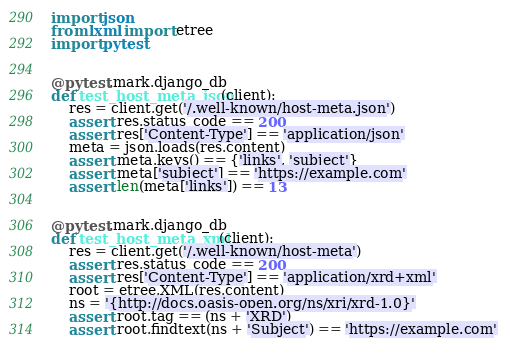Convert code to text. <code><loc_0><loc_0><loc_500><loc_500><_Python_>import json
from lxml import etree
import pytest


@pytest.mark.django_db
def test_host_meta_json(client):
    res = client.get('/.well-known/host-meta.json')
    assert res.status_code == 200
    assert res['Content-Type'] == 'application/json'
    meta = json.loads(res.content)
    assert meta.keys() == {'links', 'subject'}
    assert meta['subject'] == 'https://example.com'
    assert len(meta['links']) == 13


@pytest.mark.django_db
def test_host_meta_xml(client):
    res = client.get('/.well-known/host-meta')
    assert res.status_code == 200
    assert res['Content-Type'] == 'application/xrd+xml'
    root = etree.XML(res.content)
    ns = '{http://docs.oasis-open.org/ns/xri/xrd-1.0}'
    assert root.tag == (ns + 'XRD')
    assert root.findtext(ns + 'Subject') == 'https://example.com'</code> 